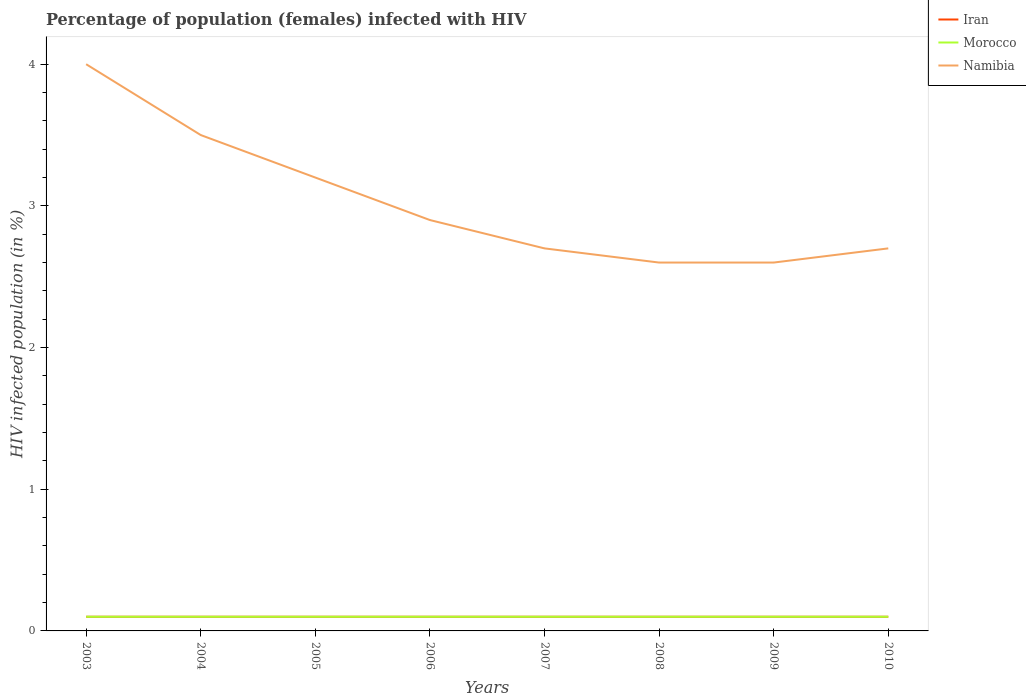How many different coloured lines are there?
Provide a short and direct response. 3. Does the line corresponding to Iran intersect with the line corresponding to Morocco?
Make the answer very short. Yes. What is the total percentage of HIV infected female population in Iran in the graph?
Offer a very short reply. 0. What is the difference between the highest and the second highest percentage of HIV infected female population in Namibia?
Provide a succinct answer. 1.4. What is the difference between the highest and the lowest percentage of HIV infected female population in Morocco?
Give a very brief answer. 0. Is the percentage of HIV infected female population in Namibia strictly greater than the percentage of HIV infected female population in Morocco over the years?
Ensure brevity in your answer.  No. What is the difference between two consecutive major ticks on the Y-axis?
Offer a terse response. 1. Are the values on the major ticks of Y-axis written in scientific E-notation?
Offer a very short reply. No. Does the graph contain any zero values?
Make the answer very short. No. Does the graph contain grids?
Offer a very short reply. No. How many legend labels are there?
Ensure brevity in your answer.  3. What is the title of the graph?
Give a very brief answer. Percentage of population (females) infected with HIV. What is the label or title of the X-axis?
Make the answer very short. Years. What is the label or title of the Y-axis?
Ensure brevity in your answer.  HIV infected population (in %). What is the HIV infected population (in %) in Morocco in 2003?
Your answer should be compact. 0.1. What is the HIV infected population (in %) in Iran in 2004?
Keep it short and to the point. 0.1. What is the HIV infected population (in %) in Iran in 2007?
Offer a very short reply. 0.1. What is the HIV infected population (in %) in Namibia in 2007?
Your response must be concise. 2.7. What is the HIV infected population (in %) in Iran in 2008?
Offer a very short reply. 0.1. What is the HIV infected population (in %) of Morocco in 2008?
Offer a very short reply. 0.1. What is the HIV infected population (in %) in Namibia in 2008?
Give a very brief answer. 2.6. What is the HIV infected population (in %) of Morocco in 2009?
Provide a succinct answer. 0.1. What is the HIV infected population (in %) of Namibia in 2009?
Ensure brevity in your answer.  2.6. What is the HIV infected population (in %) of Iran in 2010?
Your answer should be very brief. 0.1. Across all years, what is the maximum HIV infected population (in %) of Namibia?
Your answer should be compact. 4. Across all years, what is the minimum HIV infected population (in %) of Iran?
Give a very brief answer. 0.1. Across all years, what is the minimum HIV infected population (in %) in Namibia?
Your answer should be very brief. 2.6. What is the total HIV infected population (in %) in Morocco in the graph?
Give a very brief answer. 0.8. What is the total HIV infected population (in %) in Namibia in the graph?
Offer a terse response. 24.2. What is the difference between the HIV infected population (in %) of Iran in 2003 and that in 2004?
Keep it short and to the point. 0. What is the difference between the HIV infected population (in %) of Iran in 2003 and that in 2005?
Give a very brief answer. 0. What is the difference between the HIV infected population (in %) in Morocco in 2003 and that in 2005?
Provide a succinct answer. 0. What is the difference between the HIV infected population (in %) of Namibia in 2003 and that in 2005?
Keep it short and to the point. 0.8. What is the difference between the HIV infected population (in %) of Morocco in 2003 and that in 2006?
Your answer should be very brief. 0. What is the difference between the HIV infected population (in %) in Namibia in 2003 and that in 2006?
Offer a very short reply. 1.1. What is the difference between the HIV infected population (in %) of Iran in 2003 and that in 2007?
Ensure brevity in your answer.  0. What is the difference between the HIV infected population (in %) of Morocco in 2003 and that in 2007?
Offer a terse response. 0. What is the difference between the HIV infected population (in %) of Namibia in 2003 and that in 2007?
Make the answer very short. 1.3. What is the difference between the HIV infected population (in %) of Iran in 2003 and that in 2008?
Ensure brevity in your answer.  0. What is the difference between the HIV infected population (in %) of Morocco in 2003 and that in 2008?
Your answer should be very brief. 0. What is the difference between the HIV infected population (in %) in Namibia in 2003 and that in 2009?
Your response must be concise. 1.4. What is the difference between the HIV infected population (in %) of Morocco in 2003 and that in 2010?
Keep it short and to the point. 0. What is the difference between the HIV infected population (in %) of Namibia in 2003 and that in 2010?
Provide a short and direct response. 1.3. What is the difference between the HIV infected population (in %) in Iran in 2004 and that in 2005?
Keep it short and to the point. 0. What is the difference between the HIV infected population (in %) in Morocco in 2004 and that in 2005?
Provide a succinct answer. 0. What is the difference between the HIV infected population (in %) in Iran in 2004 and that in 2006?
Provide a short and direct response. 0. What is the difference between the HIV infected population (in %) of Namibia in 2004 and that in 2006?
Offer a terse response. 0.6. What is the difference between the HIV infected population (in %) in Morocco in 2004 and that in 2007?
Provide a short and direct response. 0. What is the difference between the HIV infected population (in %) of Iran in 2004 and that in 2008?
Your answer should be very brief. 0. What is the difference between the HIV infected population (in %) in Morocco in 2004 and that in 2008?
Offer a terse response. 0. What is the difference between the HIV infected population (in %) of Iran in 2004 and that in 2009?
Your answer should be compact. 0. What is the difference between the HIV infected population (in %) of Morocco in 2004 and that in 2009?
Keep it short and to the point. 0. What is the difference between the HIV infected population (in %) in Iran in 2004 and that in 2010?
Your answer should be very brief. 0. What is the difference between the HIV infected population (in %) of Namibia in 2004 and that in 2010?
Give a very brief answer. 0.8. What is the difference between the HIV infected population (in %) in Iran in 2005 and that in 2006?
Offer a very short reply. 0. What is the difference between the HIV infected population (in %) of Morocco in 2005 and that in 2006?
Ensure brevity in your answer.  0. What is the difference between the HIV infected population (in %) in Iran in 2005 and that in 2007?
Your response must be concise. 0. What is the difference between the HIV infected population (in %) of Morocco in 2005 and that in 2007?
Your answer should be compact. 0. What is the difference between the HIV infected population (in %) in Namibia in 2005 and that in 2007?
Ensure brevity in your answer.  0.5. What is the difference between the HIV infected population (in %) in Iran in 2005 and that in 2008?
Give a very brief answer. 0. What is the difference between the HIV infected population (in %) of Morocco in 2005 and that in 2008?
Provide a short and direct response. 0. What is the difference between the HIV infected population (in %) in Iran in 2005 and that in 2009?
Your answer should be very brief. 0. What is the difference between the HIV infected population (in %) of Morocco in 2005 and that in 2009?
Offer a very short reply. 0. What is the difference between the HIV infected population (in %) of Namibia in 2005 and that in 2010?
Provide a short and direct response. 0.5. What is the difference between the HIV infected population (in %) in Iran in 2006 and that in 2007?
Offer a terse response. 0. What is the difference between the HIV infected population (in %) in Iran in 2006 and that in 2009?
Offer a terse response. 0. What is the difference between the HIV infected population (in %) of Namibia in 2006 and that in 2009?
Your answer should be very brief. 0.3. What is the difference between the HIV infected population (in %) in Morocco in 2006 and that in 2010?
Make the answer very short. 0. What is the difference between the HIV infected population (in %) in Iran in 2007 and that in 2008?
Your answer should be very brief. 0. What is the difference between the HIV infected population (in %) in Namibia in 2007 and that in 2008?
Provide a short and direct response. 0.1. What is the difference between the HIV infected population (in %) of Iran in 2007 and that in 2009?
Your answer should be compact. 0. What is the difference between the HIV infected population (in %) of Iran in 2007 and that in 2010?
Provide a short and direct response. 0. What is the difference between the HIV infected population (in %) of Iran in 2008 and that in 2009?
Give a very brief answer. 0. What is the difference between the HIV infected population (in %) of Morocco in 2008 and that in 2009?
Ensure brevity in your answer.  0. What is the difference between the HIV infected population (in %) of Iran in 2008 and that in 2010?
Your answer should be compact. 0. What is the difference between the HIV infected population (in %) in Morocco in 2008 and that in 2010?
Give a very brief answer. 0. What is the difference between the HIV infected population (in %) in Iran in 2009 and that in 2010?
Ensure brevity in your answer.  0. What is the difference between the HIV infected population (in %) of Morocco in 2009 and that in 2010?
Your answer should be very brief. 0. What is the difference between the HIV infected population (in %) in Iran in 2003 and the HIV infected population (in %) in Namibia in 2004?
Your answer should be compact. -3.4. What is the difference between the HIV infected population (in %) of Iran in 2003 and the HIV infected population (in %) of Morocco in 2008?
Your answer should be compact. 0. What is the difference between the HIV infected population (in %) in Iran in 2003 and the HIV infected population (in %) in Namibia in 2008?
Your answer should be compact. -2.5. What is the difference between the HIV infected population (in %) in Morocco in 2003 and the HIV infected population (in %) in Namibia in 2008?
Ensure brevity in your answer.  -2.5. What is the difference between the HIV infected population (in %) of Iran in 2003 and the HIV infected population (in %) of Morocco in 2009?
Offer a terse response. 0. What is the difference between the HIV infected population (in %) in Iran in 2003 and the HIV infected population (in %) in Morocco in 2010?
Provide a short and direct response. 0. What is the difference between the HIV infected population (in %) of Iran in 2003 and the HIV infected population (in %) of Namibia in 2010?
Provide a succinct answer. -2.6. What is the difference between the HIV infected population (in %) in Morocco in 2003 and the HIV infected population (in %) in Namibia in 2010?
Your answer should be compact. -2.6. What is the difference between the HIV infected population (in %) of Iran in 2004 and the HIV infected population (in %) of Morocco in 2005?
Offer a terse response. 0. What is the difference between the HIV infected population (in %) of Morocco in 2004 and the HIV infected population (in %) of Namibia in 2006?
Offer a terse response. -2.8. What is the difference between the HIV infected population (in %) of Iran in 2004 and the HIV infected population (in %) of Namibia in 2007?
Ensure brevity in your answer.  -2.6. What is the difference between the HIV infected population (in %) in Morocco in 2004 and the HIV infected population (in %) in Namibia in 2007?
Offer a very short reply. -2.6. What is the difference between the HIV infected population (in %) in Iran in 2004 and the HIV infected population (in %) in Namibia in 2008?
Your answer should be very brief. -2.5. What is the difference between the HIV infected population (in %) of Iran in 2004 and the HIV infected population (in %) of Namibia in 2009?
Your answer should be very brief. -2.5. What is the difference between the HIV infected population (in %) of Morocco in 2004 and the HIV infected population (in %) of Namibia in 2009?
Your answer should be compact. -2.5. What is the difference between the HIV infected population (in %) in Iran in 2004 and the HIV infected population (in %) in Morocco in 2010?
Your response must be concise. 0. What is the difference between the HIV infected population (in %) of Iran in 2004 and the HIV infected population (in %) of Namibia in 2010?
Your answer should be compact. -2.6. What is the difference between the HIV infected population (in %) of Morocco in 2004 and the HIV infected population (in %) of Namibia in 2010?
Make the answer very short. -2.6. What is the difference between the HIV infected population (in %) in Morocco in 2005 and the HIV infected population (in %) in Namibia in 2007?
Your answer should be very brief. -2.6. What is the difference between the HIV infected population (in %) of Iran in 2005 and the HIV infected population (in %) of Morocco in 2008?
Offer a terse response. 0. What is the difference between the HIV infected population (in %) of Iran in 2005 and the HIV infected population (in %) of Namibia in 2008?
Your answer should be compact. -2.5. What is the difference between the HIV infected population (in %) of Morocco in 2005 and the HIV infected population (in %) of Namibia in 2010?
Your answer should be compact. -2.6. What is the difference between the HIV infected population (in %) of Iran in 2006 and the HIV infected population (in %) of Morocco in 2007?
Your response must be concise. 0. What is the difference between the HIV infected population (in %) in Iran in 2006 and the HIV infected population (in %) in Morocco in 2008?
Give a very brief answer. 0. What is the difference between the HIV infected population (in %) of Iran in 2006 and the HIV infected population (in %) of Namibia in 2008?
Ensure brevity in your answer.  -2.5. What is the difference between the HIV infected population (in %) of Morocco in 2006 and the HIV infected population (in %) of Namibia in 2008?
Provide a succinct answer. -2.5. What is the difference between the HIV infected population (in %) of Iran in 2007 and the HIV infected population (in %) of Morocco in 2008?
Your answer should be very brief. 0. What is the difference between the HIV infected population (in %) in Iran in 2007 and the HIV infected population (in %) in Namibia in 2008?
Your answer should be compact. -2.5. What is the difference between the HIV infected population (in %) of Iran in 2007 and the HIV infected population (in %) of Morocco in 2009?
Your answer should be compact. 0. What is the difference between the HIV infected population (in %) in Iran in 2007 and the HIV infected population (in %) in Namibia in 2010?
Provide a short and direct response. -2.6. What is the difference between the HIV infected population (in %) of Morocco in 2008 and the HIV infected population (in %) of Namibia in 2009?
Ensure brevity in your answer.  -2.5. What is the difference between the HIV infected population (in %) of Iran in 2008 and the HIV infected population (in %) of Morocco in 2010?
Your answer should be compact. 0. What is the difference between the HIV infected population (in %) in Iran in 2008 and the HIV infected population (in %) in Namibia in 2010?
Your answer should be compact. -2.6. What is the difference between the HIV infected population (in %) of Morocco in 2008 and the HIV infected population (in %) of Namibia in 2010?
Ensure brevity in your answer.  -2.6. What is the difference between the HIV infected population (in %) of Iran in 2009 and the HIV infected population (in %) of Morocco in 2010?
Make the answer very short. 0. What is the average HIV infected population (in %) of Morocco per year?
Your response must be concise. 0.1. What is the average HIV infected population (in %) in Namibia per year?
Give a very brief answer. 3.02. In the year 2003, what is the difference between the HIV infected population (in %) in Iran and HIV infected population (in %) in Namibia?
Offer a very short reply. -3.9. In the year 2003, what is the difference between the HIV infected population (in %) in Morocco and HIV infected population (in %) in Namibia?
Make the answer very short. -3.9. In the year 2005, what is the difference between the HIV infected population (in %) of Iran and HIV infected population (in %) of Morocco?
Provide a short and direct response. 0. In the year 2005, what is the difference between the HIV infected population (in %) in Morocco and HIV infected population (in %) in Namibia?
Your answer should be very brief. -3.1. In the year 2006, what is the difference between the HIV infected population (in %) in Iran and HIV infected population (in %) in Namibia?
Your answer should be very brief. -2.8. In the year 2007, what is the difference between the HIV infected population (in %) in Iran and HIV infected population (in %) in Namibia?
Provide a short and direct response. -2.6. In the year 2007, what is the difference between the HIV infected population (in %) of Morocco and HIV infected population (in %) of Namibia?
Ensure brevity in your answer.  -2.6. In the year 2008, what is the difference between the HIV infected population (in %) of Iran and HIV infected population (in %) of Morocco?
Make the answer very short. 0. In the year 2008, what is the difference between the HIV infected population (in %) in Iran and HIV infected population (in %) in Namibia?
Offer a terse response. -2.5. In the year 2008, what is the difference between the HIV infected population (in %) in Morocco and HIV infected population (in %) in Namibia?
Provide a short and direct response. -2.5. In the year 2009, what is the difference between the HIV infected population (in %) of Iran and HIV infected population (in %) of Namibia?
Provide a succinct answer. -2.5. In the year 2009, what is the difference between the HIV infected population (in %) in Morocco and HIV infected population (in %) in Namibia?
Offer a terse response. -2.5. In the year 2010, what is the difference between the HIV infected population (in %) in Iran and HIV infected population (in %) in Namibia?
Your response must be concise. -2.6. What is the ratio of the HIV infected population (in %) of Morocco in 2003 to that in 2005?
Ensure brevity in your answer.  1. What is the ratio of the HIV infected population (in %) in Namibia in 2003 to that in 2005?
Offer a very short reply. 1.25. What is the ratio of the HIV infected population (in %) of Morocco in 2003 to that in 2006?
Offer a terse response. 1. What is the ratio of the HIV infected population (in %) of Namibia in 2003 to that in 2006?
Your answer should be very brief. 1.38. What is the ratio of the HIV infected population (in %) of Iran in 2003 to that in 2007?
Provide a short and direct response. 1. What is the ratio of the HIV infected population (in %) in Namibia in 2003 to that in 2007?
Keep it short and to the point. 1.48. What is the ratio of the HIV infected population (in %) of Namibia in 2003 to that in 2008?
Keep it short and to the point. 1.54. What is the ratio of the HIV infected population (in %) of Iran in 2003 to that in 2009?
Ensure brevity in your answer.  1. What is the ratio of the HIV infected population (in %) in Namibia in 2003 to that in 2009?
Offer a very short reply. 1.54. What is the ratio of the HIV infected population (in %) of Morocco in 2003 to that in 2010?
Your response must be concise. 1. What is the ratio of the HIV infected population (in %) of Namibia in 2003 to that in 2010?
Give a very brief answer. 1.48. What is the ratio of the HIV infected population (in %) of Iran in 2004 to that in 2005?
Offer a very short reply. 1. What is the ratio of the HIV infected population (in %) of Namibia in 2004 to that in 2005?
Provide a succinct answer. 1.09. What is the ratio of the HIV infected population (in %) in Morocco in 2004 to that in 2006?
Your response must be concise. 1. What is the ratio of the HIV infected population (in %) in Namibia in 2004 to that in 2006?
Your response must be concise. 1.21. What is the ratio of the HIV infected population (in %) of Morocco in 2004 to that in 2007?
Ensure brevity in your answer.  1. What is the ratio of the HIV infected population (in %) of Namibia in 2004 to that in 2007?
Your answer should be compact. 1.3. What is the ratio of the HIV infected population (in %) of Iran in 2004 to that in 2008?
Your answer should be compact. 1. What is the ratio of the HIV infected population (in %) in Morocco in 2004 to that in 2008?
Provide a short and direct response. 1. What is the ratio of the HIV infected population (in %) of Namibia in 2004 to that in 2008?
Offer a terse response. 1.35. What is the ratio of the HIV infected population (in %) of Morocco in 2004 to that in 2009?
Offer a terse response. 1. What is the ratio of the HIV infected population (in %) of Namibia in 2004 to that in 2009?
Keep it short and to the point. 1.35. What is the ratio of the HIV infected population (in %) in Namibia in 2004 to that in 2010?
Your answer should be very brief. 1.3. What is the ratio of the HIV infected population (in %) of Iran in 2005 to that in 2006?
Ensure brevity in your answer.  1. What is the ratio of the HIV infected population (in %) of Morocco in 2005 to that in 2006?
Keep it short and to the point. 1. What is the ratio of the HIV infected population (in %) in Namibia in 2005 to that in 2006?
Offer a very short reply. 1.1. What is the ratio of the HIV infected population (in %) in Iran in 2005 to that in 2007?
Offer a terse response. 1. What is the ratio of the HIV infected population (in %) in Morocco in 2005 to that in 2007?
Make the answer very short. 1. What is the ratio of the HIV infected population (in %) of Namibia in 2005 to that in 2007?
Your response must be concise. 1.19. What is the ratio of the HIV infected population (in %) in Iran in 2005 to that in 2008?
Your response must be concise. 1. What is the ratio of the HIV infected population (in %) in Morocco in 2005 to that in 2008?
Provide a short and direct response. 1. What is the ratio of the HIV infected population (in %) of Namibia in 2005 to that in 2008?
Your answer should be very brief. 1.23. What is the ratio of the HIV infected population (in %) in Iran in 2005 to that in 2009?
Provide a succinct answer. 1. What is the ratio of the HIV infected population (in %) of Morocco in 2005 to that in 2009?
Your response must be concise. 1. What is the ratio of the HIV infected population (in %) in Namibia in 2005 to that in 2009?
Keep it short and to the point. 1.23. What is the ratio of the HIV infected population (in %) in Iran in 2005 to that in 2010?
Make the answer very short. 1. What is the ratio of the HIV infected population (in %) in Namibia in 2005 to that in 2010?
Make the answer very short. 1.19. What is the ratio of the HIV infected population (in %) in Morocco in 2006 to that in 2007?
Make the answer very short. 1. What is the ratio of the HIV infected population (in %) of Namibia in 2006 to that in 2007?
Offer a terse response. 1.07. What is the ratio of the HIV infected population (in %) in Iran in 2006 to that in 2008?
Keep it short and to the point. 1. What is the ratio of the HIV infected population (in %) of Morocco in 2006 to that in 2008?
Your answer should be compact. 1. What is the ratio of the HIV infected population (in %) in Namibia in 2006 to that in 2008?
Provide a short and direct response. 1.12. What is the ratio of the HIV infected population (in %) in Namibia in 2006 to that in 2009?
Offer a terse response. 1.12. What is the ratio of the HIV infected population (in %) in Namibia in 2006 to that in 2010?
Your answer should be compact. 1.07. What is the ratio of the HIV infected population (in %) of Namibia in 2007 to that in 2008?
Your answer should be very brief. 1.04. What is the ratio of the HIV infected population (in %) in Iran in 2007 to that in 2009?
Your answer should be very brief. 1. What is the ratio of the HIV infected population (in %) in Morocco in 2007 to that in 2009?
Give a very brief answer. 1. What is the ratio of the HIV infected population (in %) of Namibia in 2007 to that in 2009?
Your answer should be very brief. 1.04. What is the ratio of the HIV infected population (in %) in Iran in 2007 to that in 2010?
Ensure brevity in your answer.  1. What is the ratio of the HIV infected population (in %) of Morocco in 2007 to that in 2010?
Make the answer very short. 1. What is the ratio of the HIV infected population (in %) of Morocco in 2008 to that in 2010?
Ensure brevity in your answer.  1. What is the ratio of the HIV infected population (in %) in Namibia in 2008 to that in 2010?
Your answer should be very brief. 0.96. What is the difference between the highest and the lowest HIV infected population (in %) of Morocco?
Ensure brevity in your answer.  0. What is the difference between the highest and the lowest HIV infected population (in %) in Namibia?
Offer a very short reply. 1.4. 